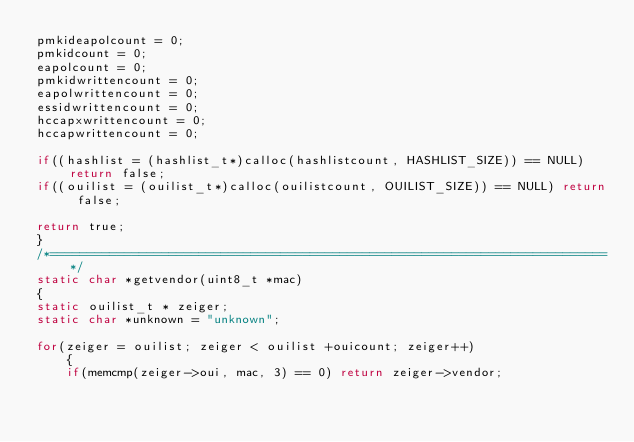Convert code to text. <code><loc_0><loc_0><loc_500><loc_500><_C_>pmkideapolcount = 0;
pmkidcount = 0;
eapolcount = 0;
pmkidwrittencount = 0;
eapolwrittencount = 0;
essidwrittencount = 0;
hccapxwrittencount = 0;
hccapwrittencount = 0;

if((hashlist = (hashlist_t*)calloc(hashlistcount, HASHLIST_SIZE)) == NULL) return false;
if((ouilist = (ouilist_t*)calloc(ouilistcount, OUILIST_SIZE)) == NULL) return false;

return true;
}
/*===========================================================================*/
static char *getvendor(uint8_t *mac)
{
static ouilist_t * zeiger;
static char *unknown = "unknown";

for(zeiger = ouilist; zeiger < ouilist +ouicount; zeiger++)
	{
	if(memcmp(zeiger->oui, mac, 3) == 0) return zeiger->vendor;</code> 